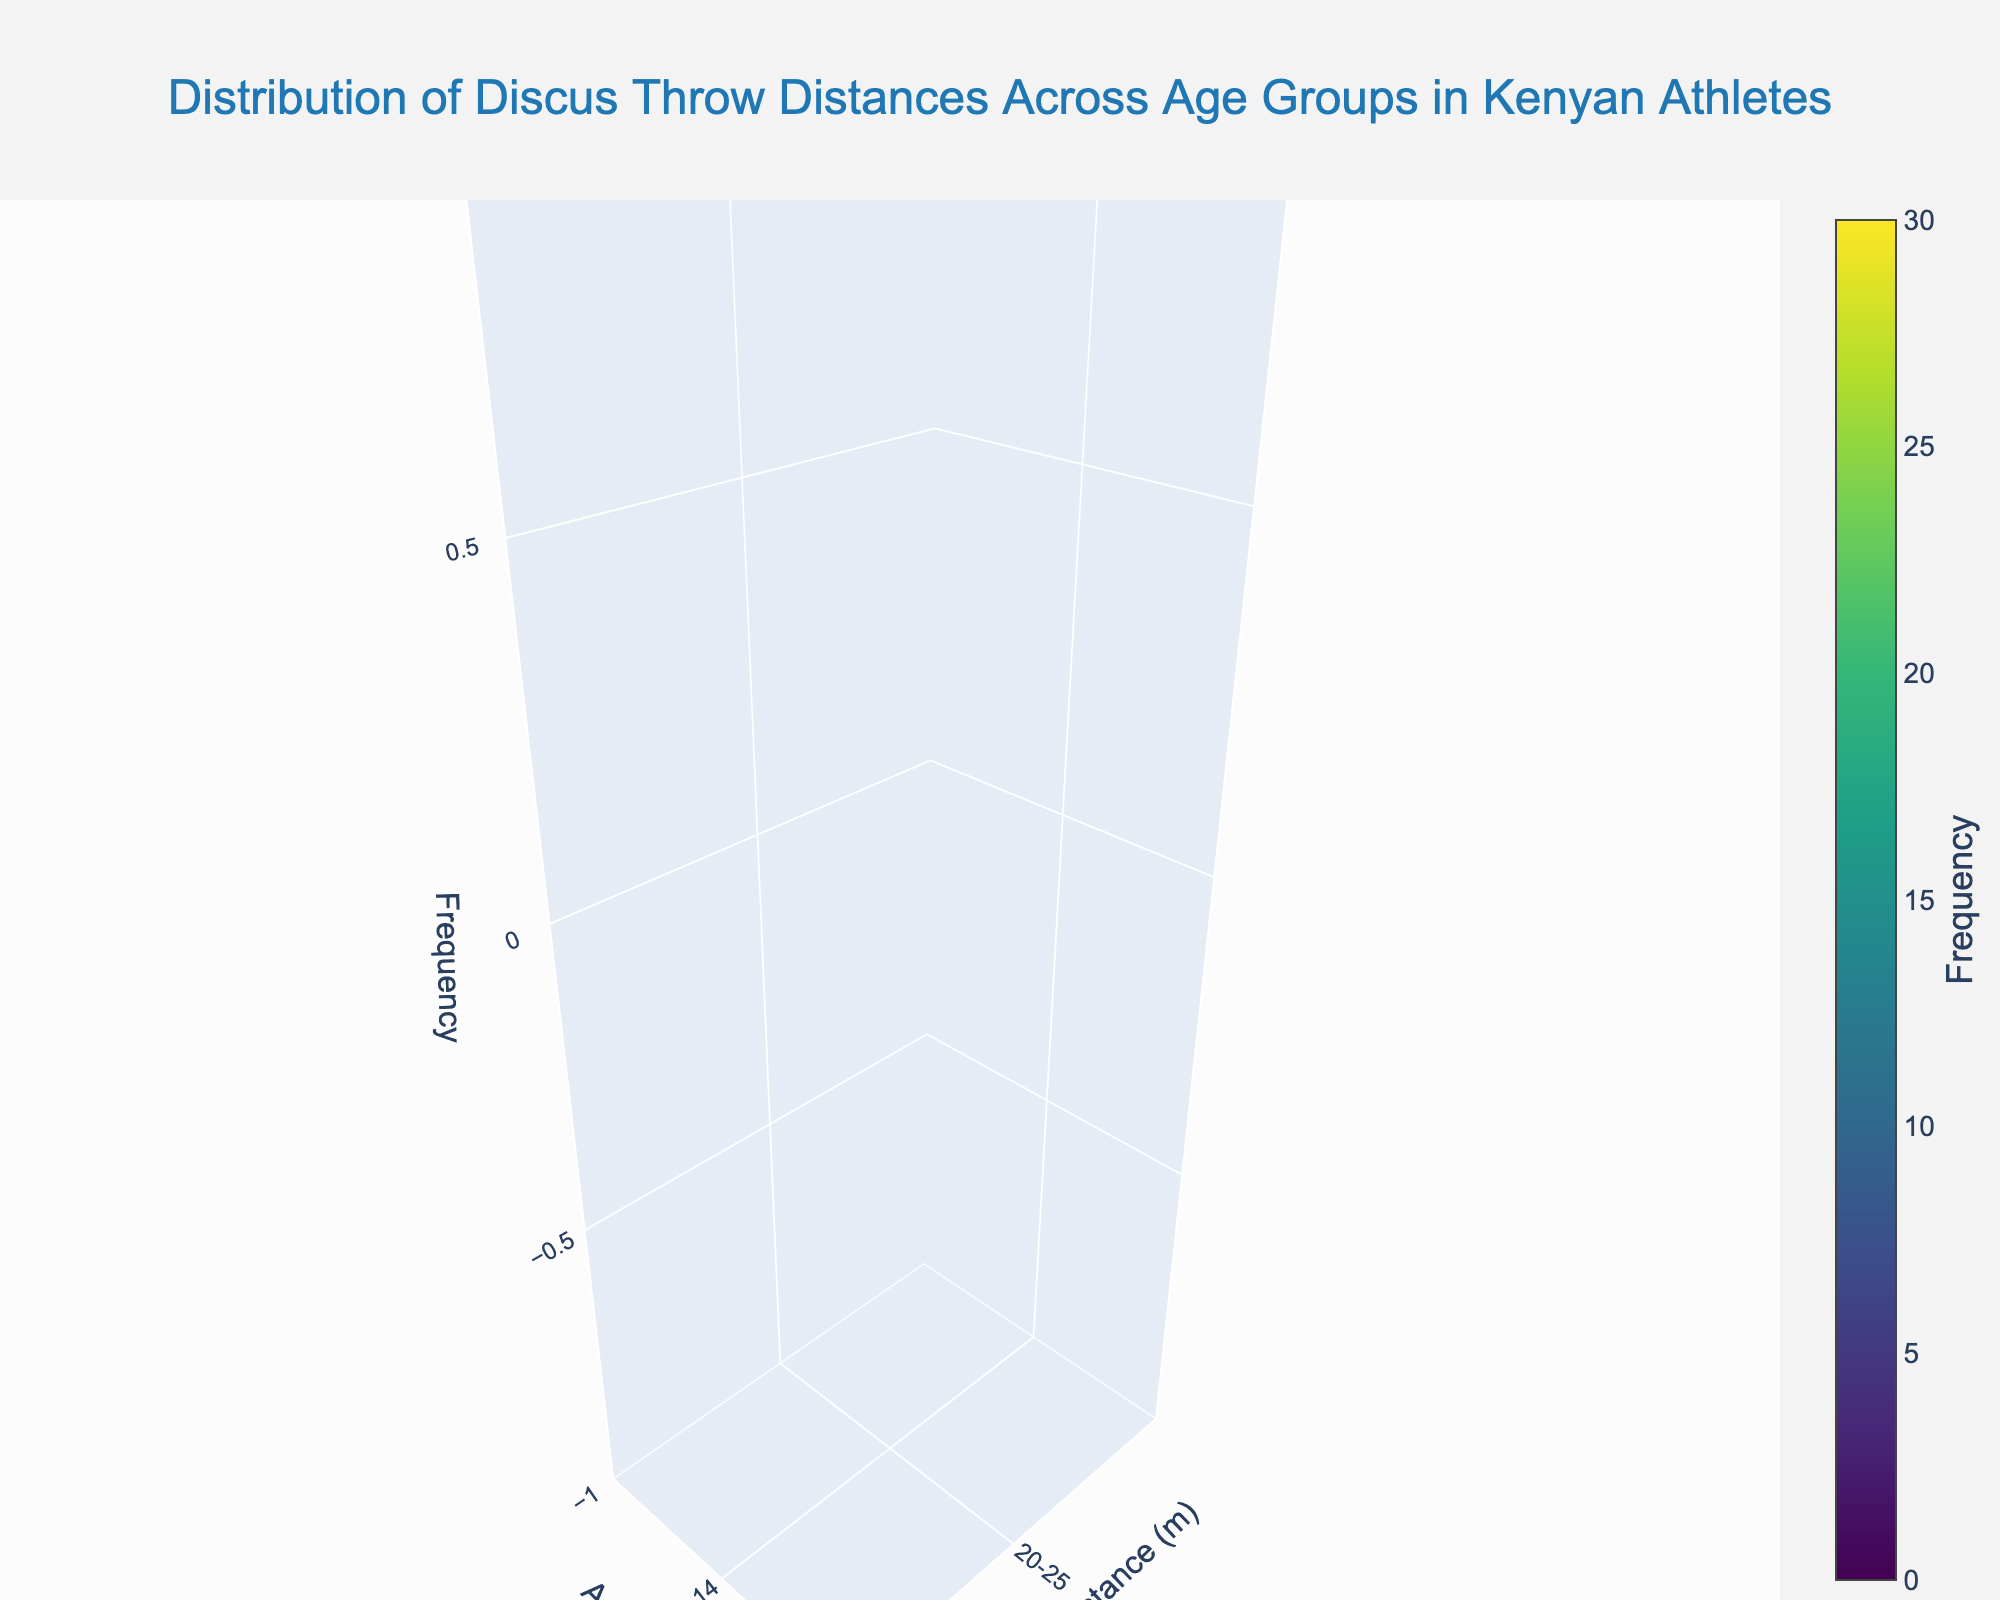What is the title of the figure? The title is usually located at the top of the figure. In this figure, the title is specified within the `title` section of the plot's layout.
Answer: Distribution of Discus Throw Distances Across Age Groups in Kenyan Athletes Which age group has the highest frequency of throws in the 20-25 meters range? The frequency of throws in the 20-25 meters range can be seen on the x-axis, while the age groups are listed on the y-axis. By examining the z-axis values (frequency), we identify that the age group 12-14 has the highest frequency in the 20-25 meters range.
Answer: 12-14 Among the age groups 15-17 and 18-20, which has a greater number of throws in the 35-40 meters range? For the age groups 15-17 and 18-20, we examine the z-axis values corresponding to the 35-40 distance range. The frequency for 15-17 is 8, while for 18-20, it is 20.
Answer: 18-20 What is the total frequency of throws for the age group 24-26 across all distances? To find the total frequency for the 24-26 age group, sum up the z-axis values for this group across all distances: 40-45 (18), 45-50 (24), and 50-55 (14). The sum is 18 + 24 + 14 = 56.
Answer: 56 Which distance range has the highest frequency overall? To determine the distance range with the highest frequency, identify the highest z-axis value. The plot shows that the 55-60 meters range has the highest frequency at 28 for the 30+ group.
Answer: 55-60 How does the frequency of throws in the 50-55 meters range for the 27-29 age group compare to the 30+ age group? To compare, check the z-axis values for both age groups in the 50-55 distance range. The frequency for the 27-29 age group is 26, while for the 30+ age group, it is 22.
Answer: 27-29 > 30+ For the 15-17 age group, what is the average frequency of throws in the 25-30 meters and 30-35 meters ranges? Calculate the average frequency by summing the frequencies for the 25-30 meters (12) and 30-35 meters (18) ranges and then dividing by 2: (12 + 18) / 2 = 15.
Answer: 15 What age group has the most variation in throw distances, based on the frequency? To find the age group with the most variation, check the frequency differences across the distance ranges for each age group. The 30+ age group shows high variation, with frequencies ranging from 18 to 28.
Answer: 30+ Which distance range shows the least variation in throw frequency across all age groups? Examine the frequency values for each distance range across all age groups. The 30-35 meters range shows fewer variations compared to other ranges, with values scattered between 5 and 18.
Answer: 30-35 